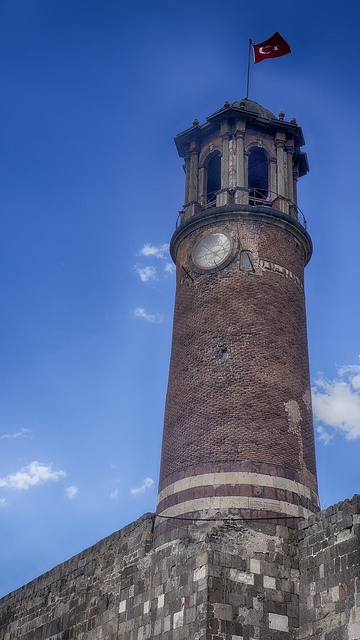Describe the objects in this image and their specific colors. I can see a clock in blue, gray, and darkgray tones in this image. 